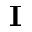Convert formula to latex. <formula><loc_0><loc_0><loc_500><loc_500>{ I }</formula> 